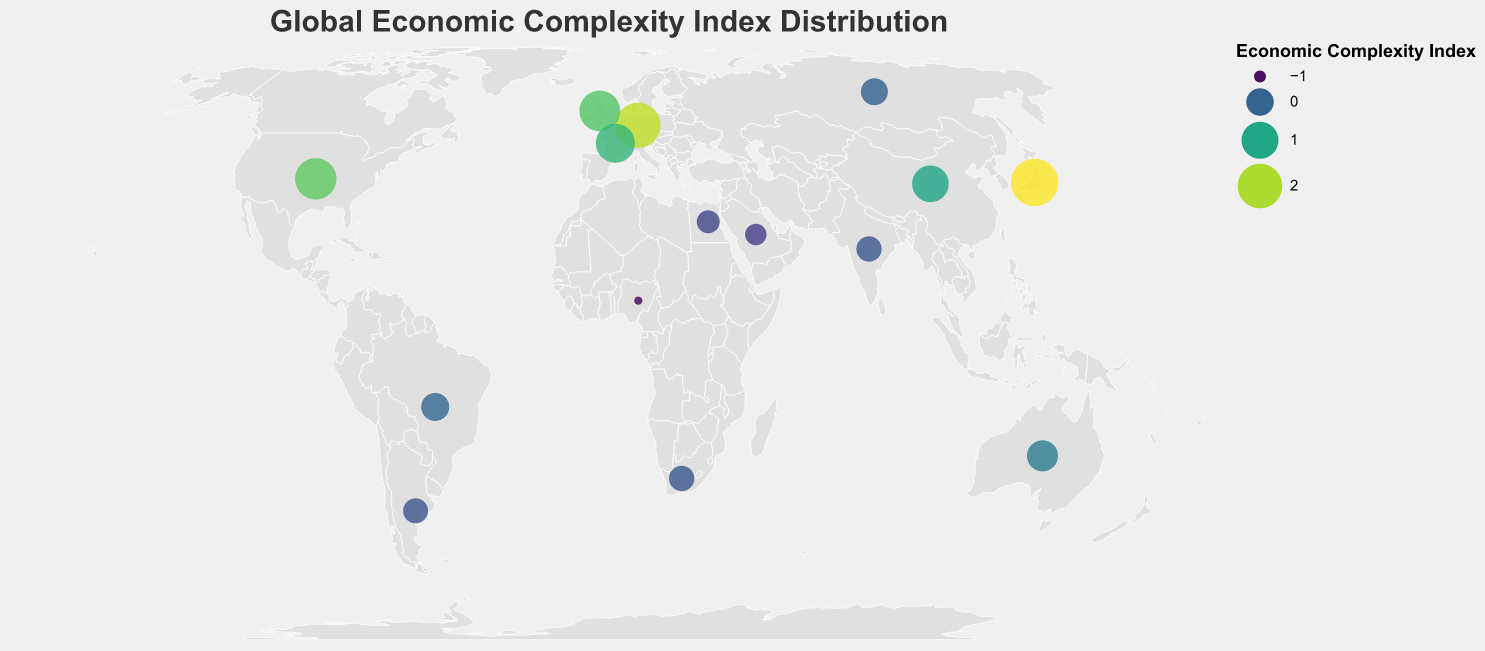What is the title of the figure? The title of the figure can be found at the top, usually written in a larger font size for emphasis. It reads "Global Economic Complexity Index Distribution"
Answer: Global Economic Complexity Index Distribution How many countries are represented in the figure? Count the number of distinct data points or circles on the map. Since the data values for each country are listed, there are 15 countries represented.
Answer: 15 Which country has the highest Economic Complexity Index? Look for the circle with the largest size and most intense color, which corresponds to the highest index value. According to the data and visualization, Japan has the highest Economic Complexity Index of 2.43.
Answer: Japan Which country is shown with the lowest Economic Complexity Index, and what is its value? Identify the circle with the smallest size and least intense color, which corresponds to the lowest index value. Based on the data, Nigeria has the lowest index value of -1.12.
Answer: Nigeria, -1.12 Compare the Economic Complexity Index of Japan and Germany. Which one is higher and by how much? The Economic Complexity Index for Japan is 2.43 and for Germany is 2.09. Subtract Germany's index from Japan's index to find the difference: 2.43 - 2.09 = 0.34. Hence, Japan's index is higher by 0.34.
Answer: Japan is higher by 0.34 Among the listed countries, which one in the Southern Hemisphere has the highest Economic Complexity Index? Identify the countries located in the Southern Hemisphere (those with negative latitudes) and compare their index values. Australia has the highest Economic Complexity Index of 0.35 among them.
Answer: Australia Which two countries have an identical Economic Complexity Index? Look for countries with the same Index value in the data list or visual representation. Both India and South Africa have an Economic Complexity Index of -0.18.
Answer: India and South Africa What is the average Economic Complexity Index of the countries in Europe? (Germany, United Kingdom, France) Add the index values of the European countries (Germany: 2.09, United Kingdom: 1.48, France: 1.25) and divide by the number of countries: (2.09 + 1.48 + 1.25) / 3 = 1.61
Answer: 1.61 How does the Economic Complexity Index of China compare to that of the United States? The Economic Complexity Index for China is 0.97 and for the United States is 1.55. Subtract China’s index from the United States’ index: 1.55 - 0.97 = 0.58. The United States' index is higher by 0.58.
Answer: The United States' index is higher by 0.58 What is the geographic coordinate (latitude and longitude) for Egypt? Look at the data for Egypt which shows the coordinates. Egypt has a latitude of 26.8206 and a longitude of 30.8025.
Answer: Latitude: 26.8206, Longitude: 30.8025 